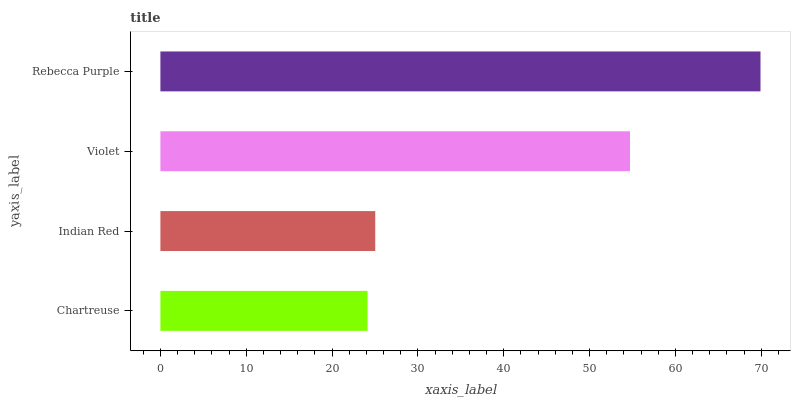Is Chartreuse the minimum?
Answer yes or no. Yes. Is Rebecca Purple the maximum?
Answer yes or no. Yes. Is Indian Red the minimum?
Answer yes or no. No. Is Indian Red the maximum?
Answer yes or no. No. Is Indian Red greater than Chartreuse?
Answer yes or no. Yes. Is Chartreuse less than Indian Red?
Answer yes or no. Yes. Is Chartreuse greater than Indian Red?
Answer yes or no. No. Is Indian Red less than Chartreuse?
Answer yes or no. No. Is Violet the high median?
Answer yes or no. Yes. Is Indian Red the low median?
Answer yes or no. Yes. Is Chartreuse the high median?
Answer yes or no. No. Is Violet the low median?
Answer yes or no. No. 